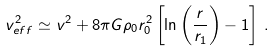<formula> <loc_0><loc_0><loc_500><loc_500>v _ { e f f } ^ { 2 } \simeq v ^ { 2 } + 8 \pi G \rho _ { 0 } r _ { 0 } ^ { 2 } \left [ \ln \left ( \frac { r } { r _ { 1 } } \right ) - 1 \right ] \, .</formula> 